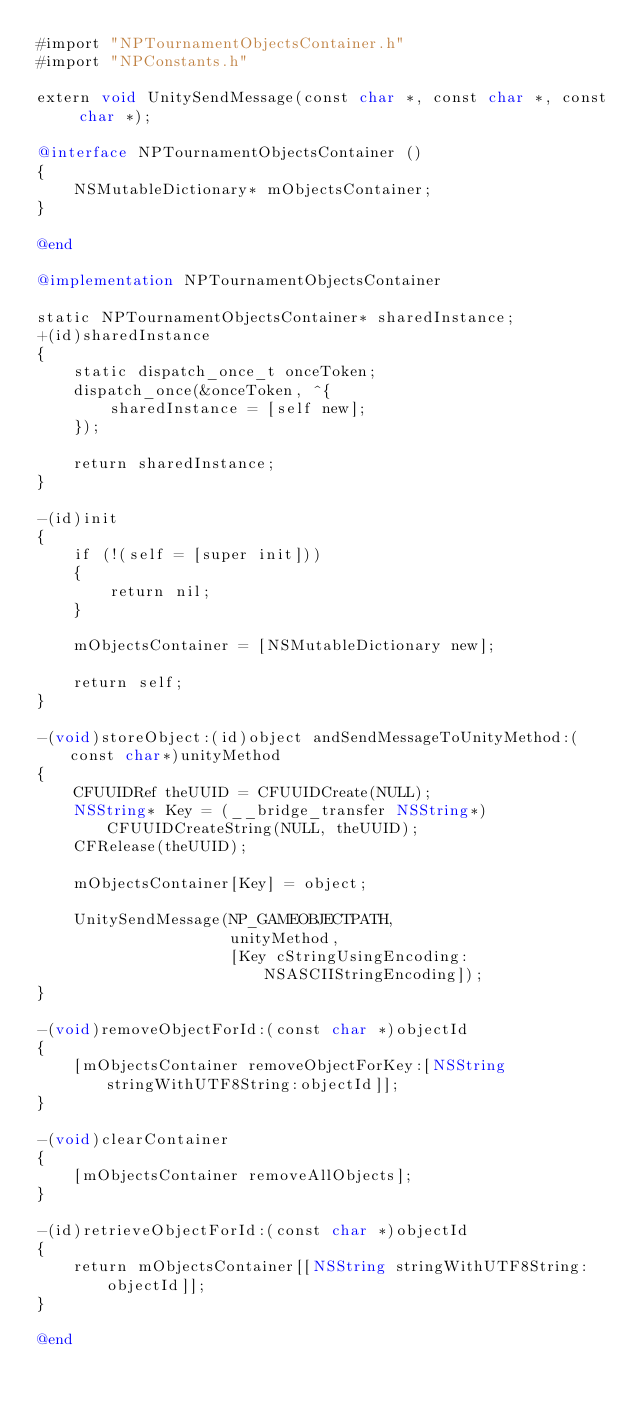Convert code to text. <code><loc_0><loc_0><loc_500><loc_500><_ObjectiveC_>#import "NPTournamentObjectsContainer.h"
#import "NPConstants.h"

extern void UnitySendMessage(const char *, const char *, const char *);

@interface NPTournamentObjectsContainer ()
{
    NSMutableDictionary* mObjectsContainer;
}

@end

@implementation NPTournamentObjectsContainer

static NPTournamentObjectsContainer* sharedInstance;
+(id)sharedInstance
{
    static dispatch_once_t onceToken;
    dispatch_once(&onceToken, ^{
        sharedInstance = [self new];
    });
    
    return sharedInstance;
}

-(id)init
{
    if (!(self = [super init]))
    {
        return nil;
    }
    
    mObjectsContainer = [NSMutableDictionary new];
    
    return self;
}

-(void)storeObject:(id)object andSendMessageToUnityMethod:(const char*)unityMethod
{
    CFUUIDRef theUUID = CFUUIDCreate(NULL);
    NSString* Key = (__bridge_transfer NSString*)CFUUIDCreateString(NULL, theUUID);
    CFRelease(theUUID);
    
    mObjectsContainer[Key] = object;
    
    UnitySendMessage(NP_GAMEOBJECTPATH,
                     unityMethod,
                     [Key cStringUsingEncoding:NSASCIIStringEncoding]);
}

-(void)removeObjectForId:(const char *)objectId
{
    [mObjectsContainer removeObjectForKey:[NSString stringWithUTF8String:objectId]];
}

-(void)clearContainer
{
    [mObjectsContainer removeAllObjects];
}

-(id)retrieveObjectForId:(const char *)objectId
{
    return mObjectsContainer[[NSString stringWithUTF8String:objectId]];
}

@end
</code> 